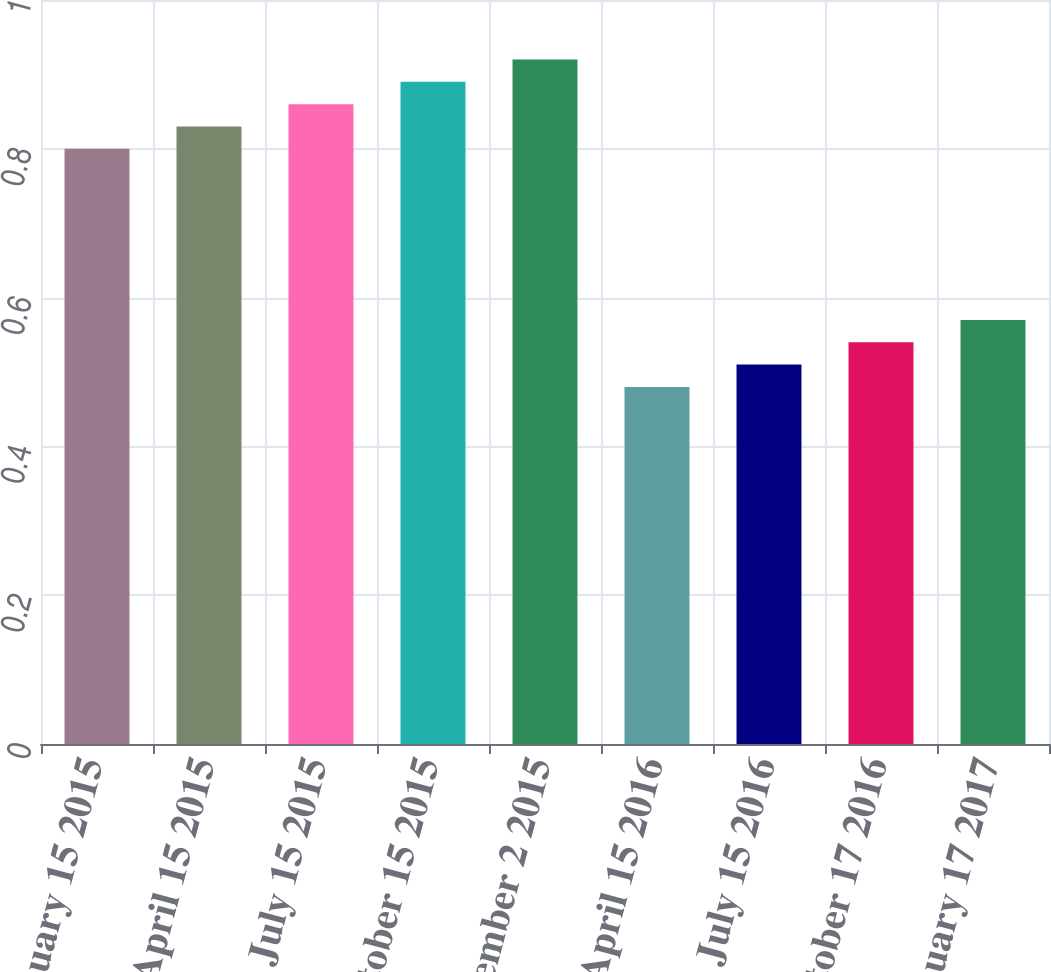Convert chart to OTSL. <chart><loc_0><loc_0><loc_500><loc_500><bar_chart><fcel>January 15 2015<fcel>April 15 2015<fcel>July 15 2015<fcel>October 15 2015<fcel>December 2 2015<fcel>April 15 2016<fcel>July 15 2016<fcel>October 17 2016<fcel>January 17 2017<nl><fcel>0.8<fcel>0.83<fcel>0.86<fcel>0.89<fcel>0.92<fcel>0.48<fcel>0.51<fcel>0.54<fcel>0.57<nl></chart> 